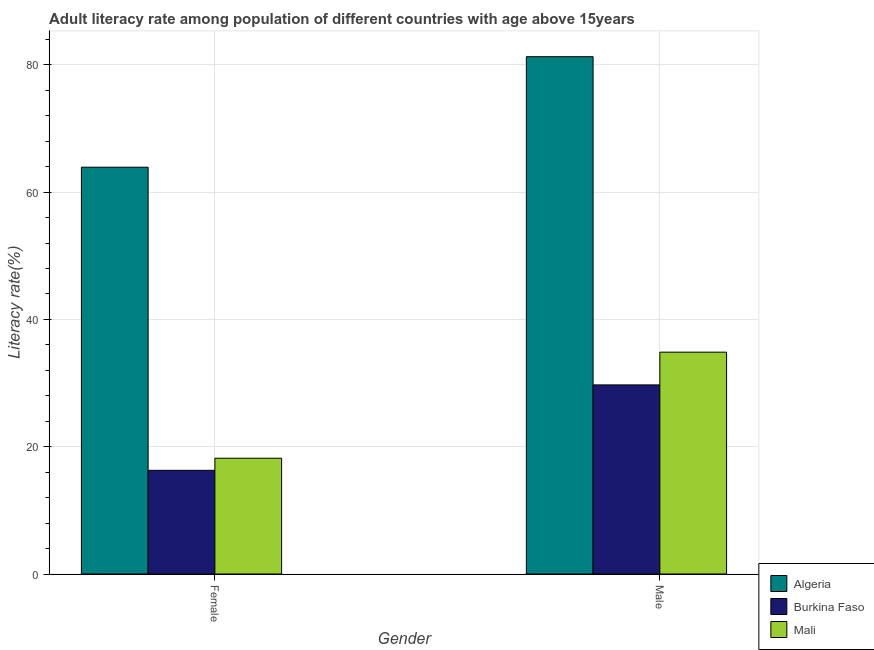How many different coloured bars are there?
Ensure brevity in your answer.  3. Are the number of bars per tick equal to the number of legend labels?
Offer a very short reply. Yes. Are the number of bars on each tick of the X-axis equal?
Your response must be concise. Yes. How many bars are there on the 2nd tick from the left?
Make the answer very short. 3. How many bars are there on the 1st tick from the right?
Keep it short and to the point. 3. What is the label of the 2nd group of bars from the left?
Your answer should be very brief. Male. What is the male adult literacy rate in Burkina Faso?
Make the answer very short. 29.71. Across all countries, what is the maximum female adult literacy rate?
Offer a very short reply. 63.92. Across all countries, what is the minimum female adult literacy rate?
Provide a short and direct response. 16.29. In which country was the male adult literacy rate maximum?
Offer a very short reply. Algeria. In which country was the male adult literacy rate minimum?
Your response must be concise. Burkina Faso. What is the total female adult literacy rate in the graph?
Provide a short and direct response. 98.4. What is the difference between the female adult literacy rate in Burkina Faso and that in Algeria?
Make the answer very short. -47.63. What is the difference between the male adult literacy rate in Mali and the female adult literacy rate in Algeria?
Provide a succinct answer. -29.06. What is the average female adult literacy rate per country?
Offer a terse response. 32.8. What is the difference between the male adult literacy rate and female adult literacy rate in Mali?
Make the answer very short. 16.67. In how many countries, is the male adult literacy rate greater than 68 %?
Give a very brief answer. 1. What is the ratio of the male adult literacy rate in Burkina Faso to that in Algeria?
Keep it short and to the point. 0.37. Is the female adult literacy rate in Mali less than that in Algeria?
Your answer should be very brief. Yes. In how many countries, is the female adult literacy rate greater than the average female adult literacy rate taken over all countries?
Ensure brevity in your answer.  1. What does the 2nd bar from the left in Male represents?
Make the answer very short. Burkina Faso. What does the 3rd bar from the right in Male represents?
Ensure brevity in your answer.  Algeria. Are all the bars in the graph horizontal?
Make the answer very short. No. What is the difference between two consecutive major ticks on the Y-axis?
Provide a short and direct response. 20. Are the values on the major ticks of Y-axis written in scientific E-notation?
Offer a very short reply. No. Does the graph contain any zero values?
Make the answer very short. No. Does the graph contain grids?
Give a very brief answer. Yes. Where does the legend appear in the graph?
Offer a terse response. Bottom right. How many legend labels are there?
Provide a short and direct response. 3. What is the title of the graph?
Your response must be concise. Adult literacy rate among population of different countries with age above 15years. Does "Bolivia" appear as one of the legend labels in the graph?
Give a very brief answer. No. What is the label or title of the Y-axis?
Your answer should be very brief. Literacy rate(%). What is the Literacy rate(%) in Algeria in Female?
Give a very brief answer. 63.92. What is the Literacy rate(%) in Burkina Faso in Female?
Ensure brevity in your answer.  16.29. What is the Literacy rate(%) in Mali in Female?
Offer a terse response. 18.19. What is the Literacy rate(%) of Algeria in Male?
Ensure brevity in your answer.  81.28. What is the Literacy rate(%) of Burkina Faso in Male?
Offer a very short reply. 29.71. What is the Literacy rate(%) of Mali in Male?
Provide a short and direct response. 34.86. Across all Gender, what is the maximum Literacy rate(%) of Algeria?
Your answer should be very brief. 81.28. Across all Gender, what is the maximum Literacy rate(%) in Burkina Faso?
Give a very brief answer. 29.71. Across all Gender, what is the maximum Literacy rate(%) of Mali?
Your response must be concise. 34.86. Across all Gender, what is the minimum Literacy rate(%) of Algeria?
Your response must be concise. 63.92. Across all Gender, what is the minimum Literacy rate(%) of Burkina Faso?
Make the answer very short. 16.29. Across all Gender, what is the minimum Literacy rate(%) of Mali?
Make the answer very short. 18.19. What is the total Literacy rate(%) in Algeria in the graph?
Your answer should be compact. 145.2. What is the total Literacy rate(%) of Burkina Faso in the graph?
Offer a terse response. 46.01. What is the total Literacy rate(%) in Mali in the graph?
Keep it short and to the point. 53.05. What is the difference between the Literacy rate(%) of Algeria in Female and that in Male?
Provide a short and direct response. -17.37. What is the difference between the Literacy rate(%) in Burkina Faso in Female and that in Male?
Give a very brief answer. -13.42. What is the difference between the Literacy rate(%) in Mali in Female and that in Male?
Your response must be concise. -16.67. What is the difference between the Literacy rate(%) in Algeria in Female and the Literacy rate(%) in Burkina Faso in Male?
Your answer should be very brief. 34.2. What is the difference between the Literacy rate(%) in Algeria in Female and the Literacy rate(%) in Mali in Male?
Provide a succinct answer. 29.06. What is the difference between the Literacy rate(%) of Burkina Faso in Female and the Literacy rate(%) of Mali in Male?
Provide a short and direct response. -18.57. What is the average Literacy rate(%) in Algeria per Gender?
Provide a short and direct response. 72.6. What is the average Literacy rate(%) in Burkina Faso per Gender?
Give a very brief answer. 23. What is the average Literacy rate(%) of Mali per Gender?
Ensure brevity in your answer.  26.52. What is the difference between the Literacy rate(%) in Algeria and Literacy rate(%) in Burkina Faso in Female?
Ensure brevity in your answer.  47.63. What is the difference between the Literacy rate(%) in Algeria and Literacy rate(%) in Mali in Female?
Give a very brief answer. 45.73. What is the difference between the Literacy rate(%) of Burkina Faso and Literacy rate(%) of Mali in Female?
Ensure brevity in your answer.  -1.9. What is the difference between the Literacy rate(%) in Algeria and Literacy rate(%) in Burkina Faso in Male?
Ensure brevity in your answer.  51.57. What is the difference between the Literacy rate(%) of Algeria and Literacy rate(%) of Mali in Male?
Your answer should be very brief. 46.43. What is the difference between the Literacy rate(%) of Burkina Faso and Literacy rate(%) of Mali in Male?
Provide a short and direct response. -5.14. What is the ratio of the Literacy rate(%) of Algeria in Female to that in Male?
Provide a succinct answer. 0.79. What is the ratio of the Literacy rate(%) of Burkina Faso in Female to that in Male?
Ensure brevity in your answer.  0.55. What is the ratio of the Literacy rate(%) in Mali in Female to that in Male?
Ensure brevity in your answer.  0.52. What is the difference between the highest and the second highest Literacy rate(%) of Algeria?
Offer a terse response. 17.37. What is the difference between the highest and the second highest Literacy rate(%) of Burkina Faso?
Make the answer very short. 13.42. What is the difference between the highest and the second highest Literacy rate(%) in Mali?
Keep it short and to the point. 16.67. What is the difference between the highest and the lowest Literacy rate(%) in Algeria?
Give a very brief answer. 17.37. What is the difference between the highest and the lowest Literacy rate(%) in Burkina Faso?
Offer a very short reply. 13.42. What is the difference between the highest and the lowest Literacy rate(%) in Mali?
Ensure brevity in your answer.  16.67. 